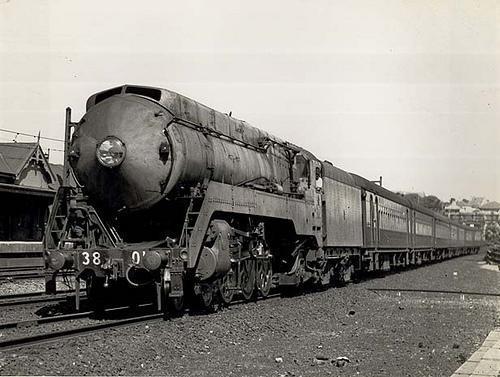How many people are pictured?
Give a very brief answer. 0. How many boxes of green apples are there?
Give a very brief answer. 0. 